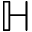Convert formula to latex. <formula><loc_0><loc_0><loc_500><loc_500>\mathbb { H }</formula> 